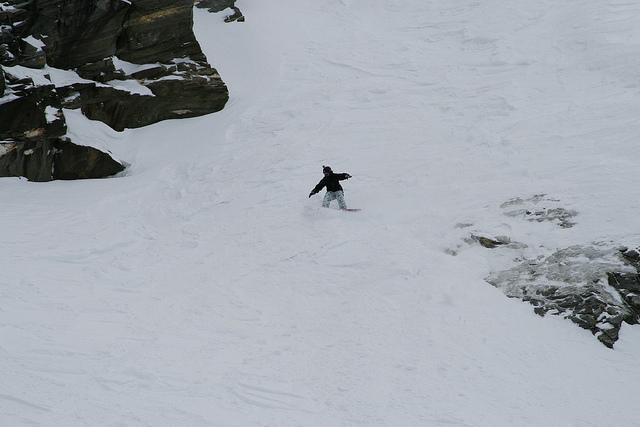How many people are visible?
Give a very brief answer. 1. 